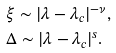<formula> <loc_0><loc_0><loc_500><loc_500>& \xi \sim | \lambda - \lambda _ { c } | ^ { - \nu } , \\ & \Delta \sim | \lambda - \lambda _ { c } | ^ { s } .</formula> 